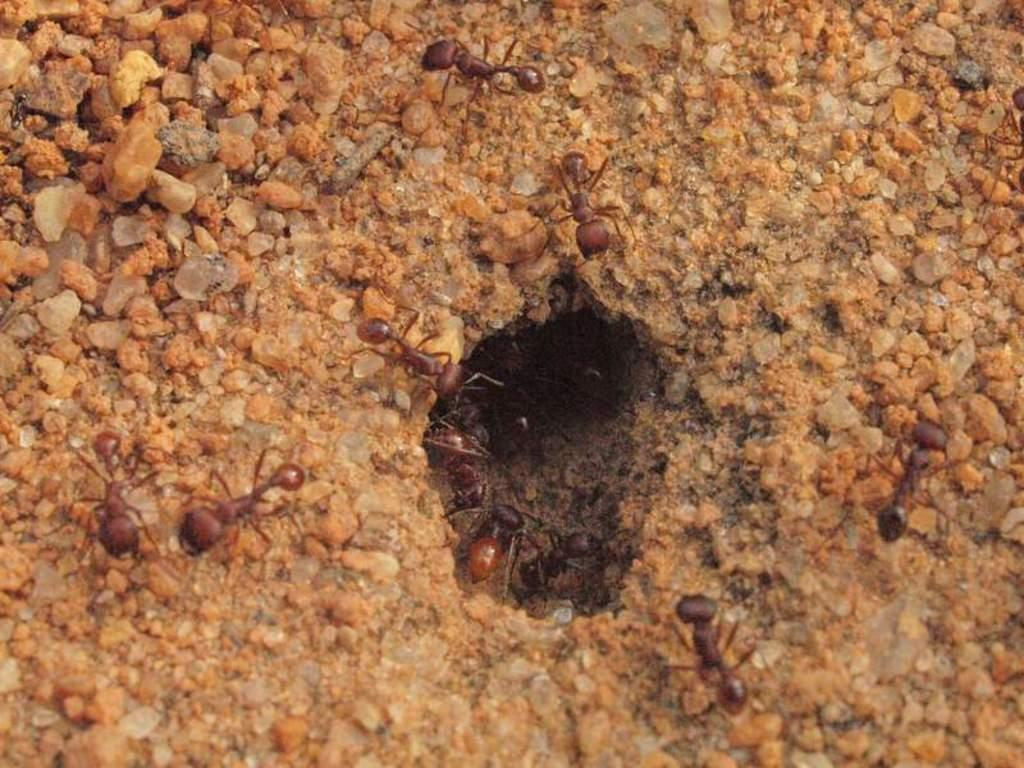What is the main setting of the image? The image depicts a ground. What type of creatures can be seen on the ground? There are ants in the image. What other objects are present on the ground? There are stones in the image. Can you describe any specific feature on the ground? There is a hole in the image. What type of fowl can be seen flying over the ground in the image? There is no fowl present in the image; it only depicts a ground with ants, stones, and a hole. What shape is the hole in the image? The provided facts do not mention the shape of the hole, so it cannot be determined from the image. 